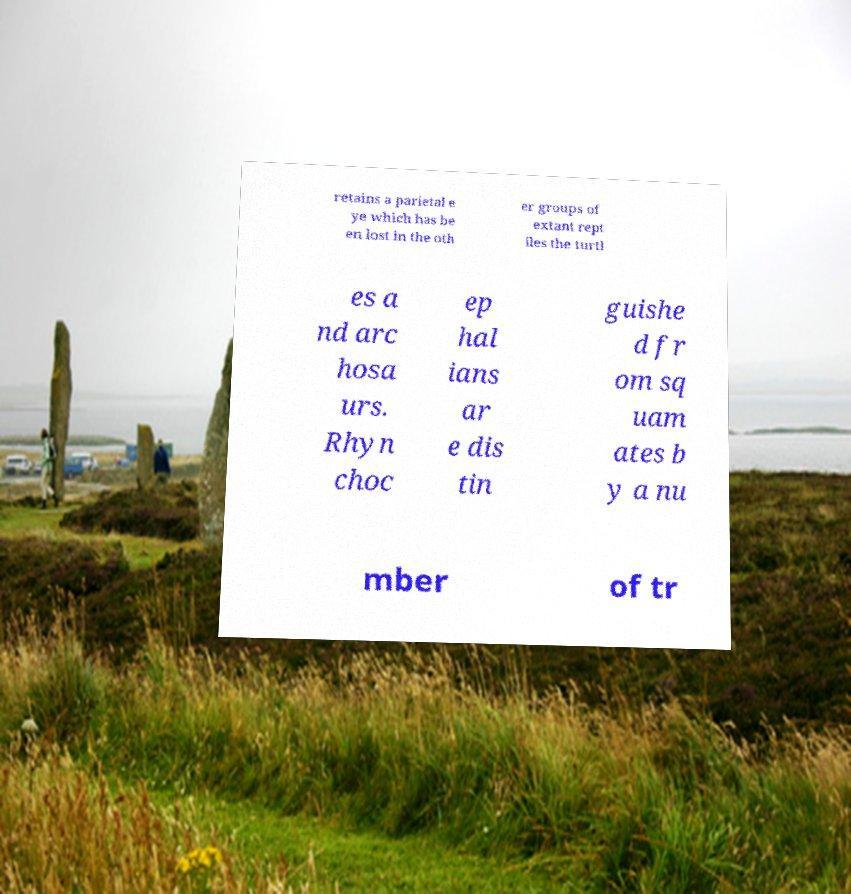What messages or text are displayed in this image? I need them in a readable, typed format. retains a parietal e ye which has be en lost in the oth er groups of extant rept iles the turtl es a nd arc hosa urs. Rhyn choc ep hal ians ar e dis tin guishe d fr om sq uam ates b y a nu mber of tr 